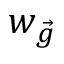Convert formula to latex. <formula><loc_0><loc_0><loc_500><loc_500>w _ { \vec { g } }</formula> 